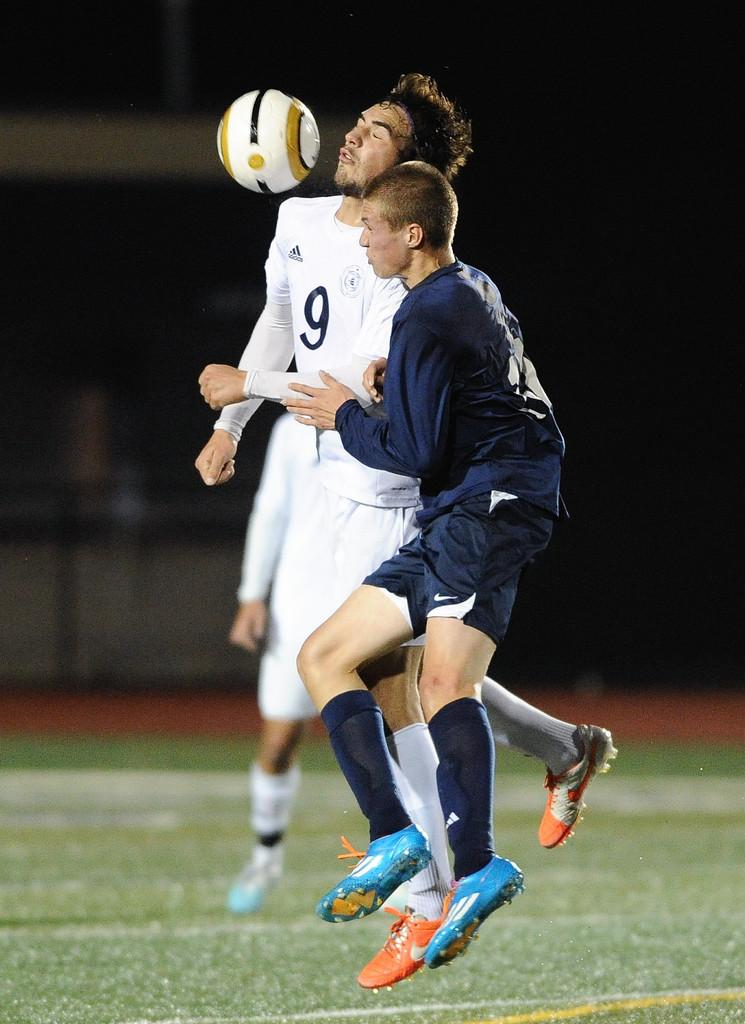<image>
Share a concise interpretation of the image provided. Two guys playing soccer, one in dark blue and one in white with a 9 on his shirt. 